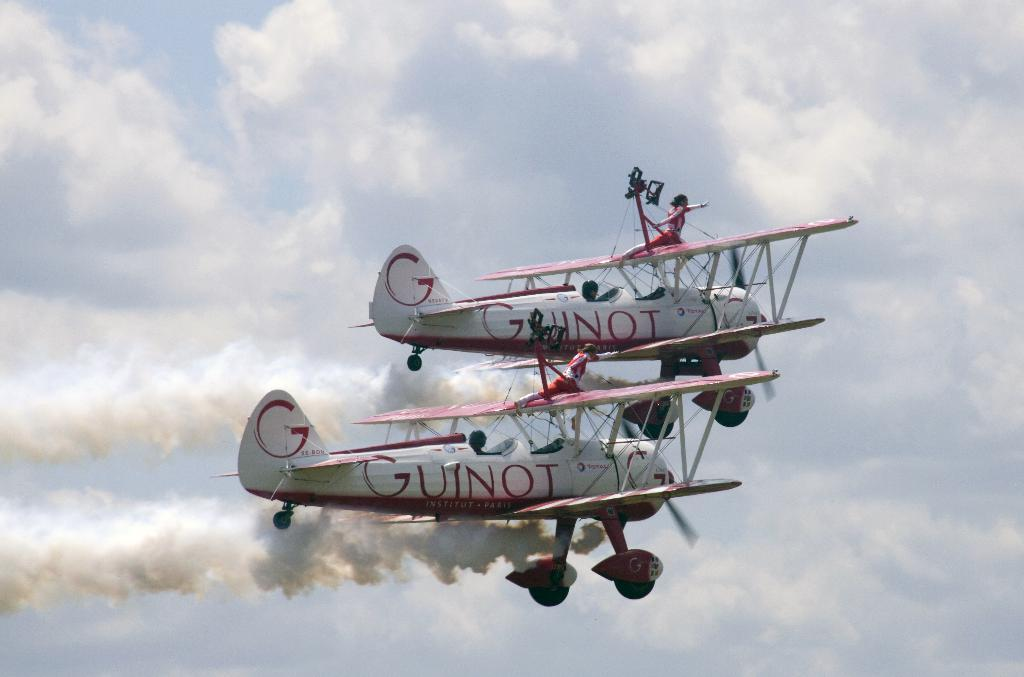Provide a one-sentence caption for the provided image. Two airplanes flying side by side with the word Guinot written on the sides of both of them. 